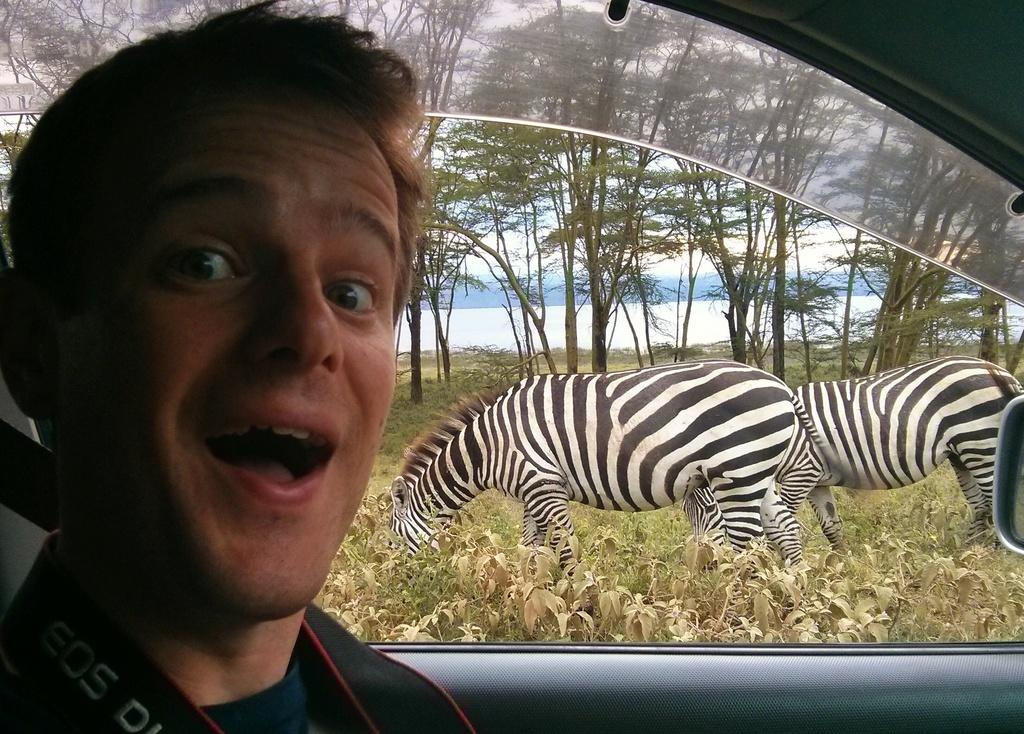What is the person in the image doing? There is a person sitting inside a car in the image. What animals can be seen in the image? There are two zebras grazing grass in the image. What type of vegetation is visible in the background of the image? Trees are visible in the background of the image. What body of water can be seen in the background of the image? There is a lake in the background of the image. What type of operation is being performed on the zebras in the image? There is no operation being performed on the zebras in the image; they are simply grazing grass. How many spiders are visible in the image? There are no spiders visible in the image. 